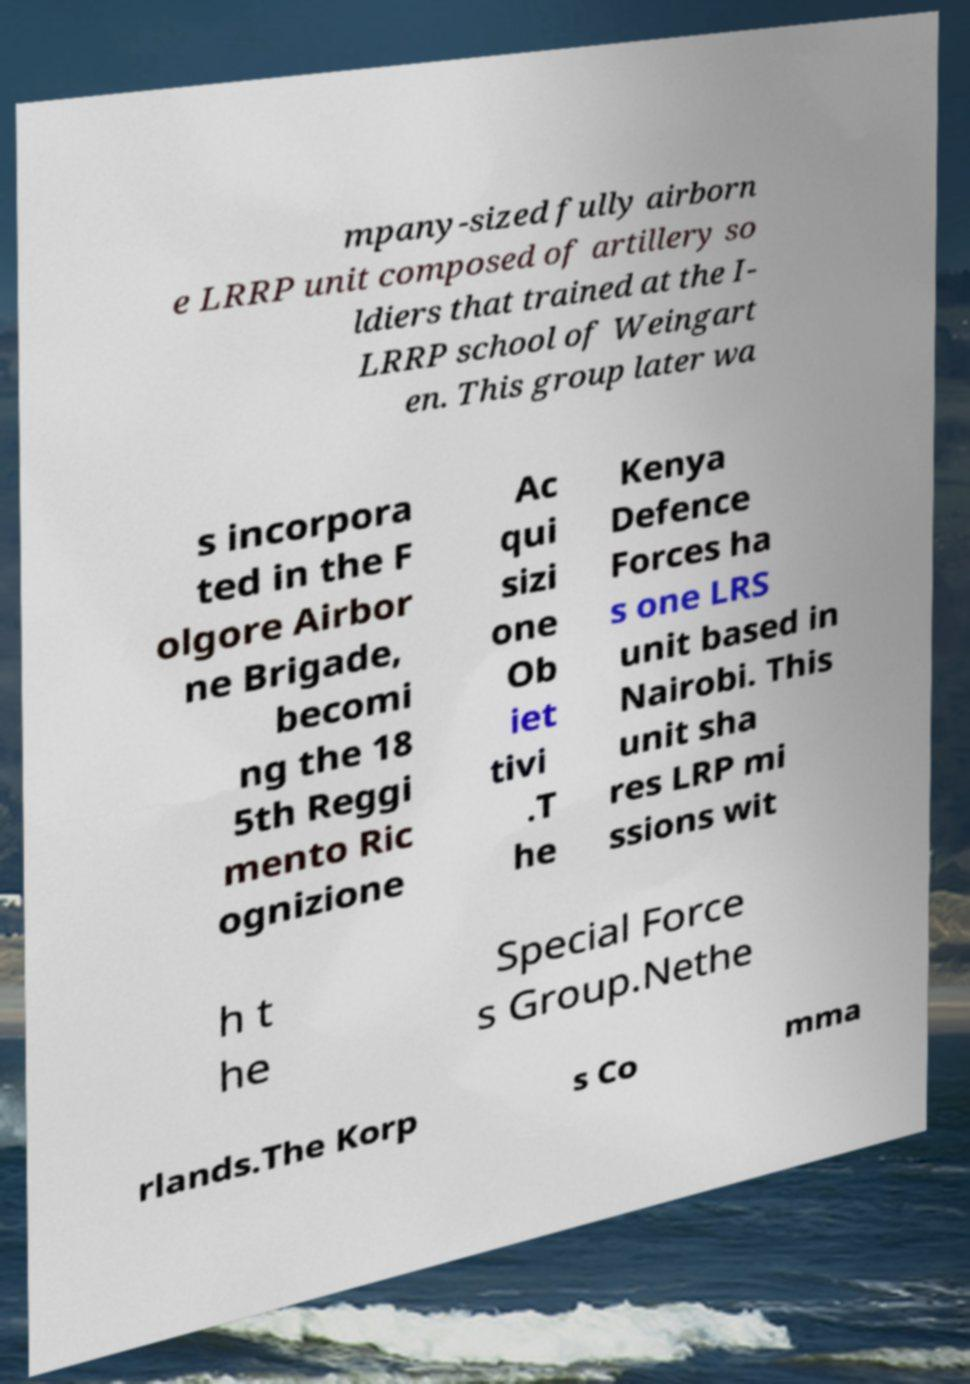What messages or text are displayed in this image? I need them in a readable, typed format. mpany-sized fully airborn e LRRP unit composed of artillery so ldiers that trained at the I- LRRP school of Weingart en. This group later wa s incorpora ted in the F olgore Airbor ne Brigade, becomi ng the 18 5th Reggi mento Ric ognizione Ac qui sizi one Ob iet tivi .T he Kenya Defence Forces ha s one LRS unit based in Nairobi. This unit sha res LRP mi ssions wit h t he Special Force s Group.Nethe rlands.The Korp s Co mma 